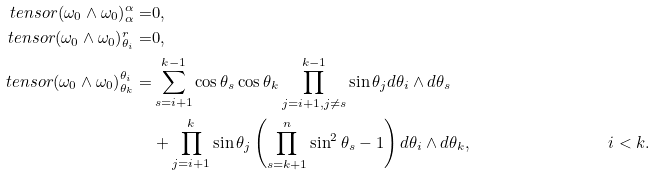<formula> <loc_0><loc_0><loc_500><loc_500>\ t e n s o r { ( \omega _ { 0 } \wedge \omega _ { 0 } ) } { ^ { \alpha } _ { \alpha } } = & 0 , \\ \ t e n s o r { ( \omega _ { 0 } \wedge \omega _ { 0 } ) } { ^ { r } _ { \theta _ { i } } } = & 0 , \\ \ t e n s o r { ( \omega _ { 0 } \wedge \omega _ { 0 } ) } { ^ { \theta _ { i } } _ { \theta _ { k } } } = & \sum _ { s = i + 1 } ^ { k - 1 } \cos { \theta _ { s } } \cos { \theta _ { k } } \prod _ { j = i + 1 , j \neq s } ^ { k - 1 } \sin { \theta _ { j } } d \theta _ { i } \wedge d \theta _ { s } \\ & + \prod _ { j = i + 1 } ^ { k } \sin { \theta _ { j } } \left ( \prod _ { s = k + 1 } ^ { n } \sin ^ { 2 } { \theta _ { s } } - 1 \right ) d \theta _ { i } \wedge d \theta _ { k } , & i < k .</formula> 